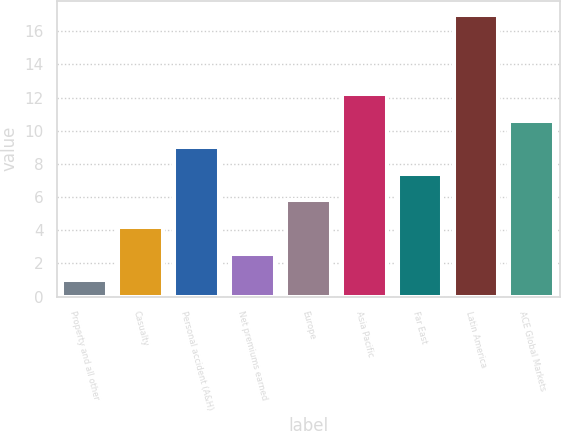Convert chart. <chart><loc_0><loc_0><loc_500><loc_500><bar_chart><fcel>Property and all other<fcel>Casualty<fcel>Personal accident (A&H)<fcel>Net premiums earned<fcel>Europe<fcel>Asia Pacific<fcel>Far East<fcel>Latin America<fcel>ACE Global Markets<nl><fcel>1<fcel>4.2<fcel>9<fcel>2.6<fcel>5.8<fcel>12.2<fcel>7.4<fcel>17<fcel>10.6<nl></chart> 